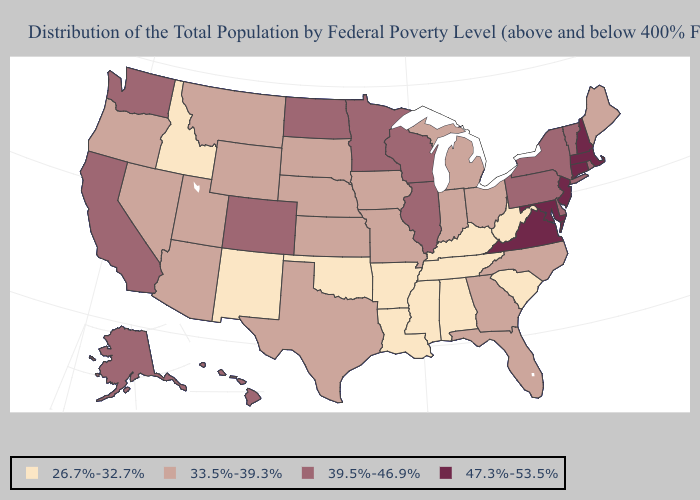Does the first symbol in the legend represent the smallest category?
Answer briefly. Yes. Name the states that have a value in the range 39.5%-46.9%?
Write a very short answer. Alaska, California, Colorado, Delaware, Hawaii, Illinois, Minnesota, New York, North Dakota, Pennsylvania, Rhode Island, Vermont, Washington, Wisconsin. Name the states that have a value in the range 33.5%-39.3%?
Write a very short answer. Arizona, Florida, Georgia, Indiana, Iowa, Kansas, Maine, Michigan, Missouri, Montana, Nebraska, Nevada, North Carolina, Ohio, Oregon, South Dakota, Texas, Utah, Wyoming. Name the states that have a value in the range 39.5%-46.9%?
Write a very short answer. Alaska, California, Colorado, Delaware, Hawaii, Illinois, Minnesota, New York, North Dakota, Pennsylvania, Rhode Island, Vermont, Washington, Wisconsin. Name the states that have a value in the range 47.3%-53.5%?
Short answer required. Connecticut, Maryland, Massachusetts, New Hampshire, New Jersey, Virginia. What is the value of Indiana?
Short answer required. 33.5%-39.3%. What is the highest value in the South ?
Keep it brief. 47.3%-53.5%. Name the states that have a value in the range 26.7%-32.7%?
Write a very short answer. Alabama, Arkansas, Idaho, Kentucky, Louisiana, Mississippi, New Mexico, Oklahoma, South Carolina, Tennessee, West Virginia. Which states have the highest value in the USA?
Keep it brief. Connecticut, Maryland, Massachusetts, New Hampshire, New Jersey, Virginia. Name the states that have a value in the range 33.5%-39.3%?
Answer briefly. Arizona, Florida, Georgia, Indiana, Iowa, Kansas, Maine, Michigan, Missouri, Montana, Nebraska, Nevada, North Carolina, Ohio, Oregon, South Dakota, Texas, Utah, Wyoming. What is the value of Massachusetts?
Keep it brief. 47.3%-53.5%. Does Connecticut have the highest value in the USA?
Give a very brief answer. Yes. Does Missouri have a lower value than Colorado?
Write a very short answer. Yes. Does the first symbol in the legend represent the smallest category?
Write a very short answer. Yes. 